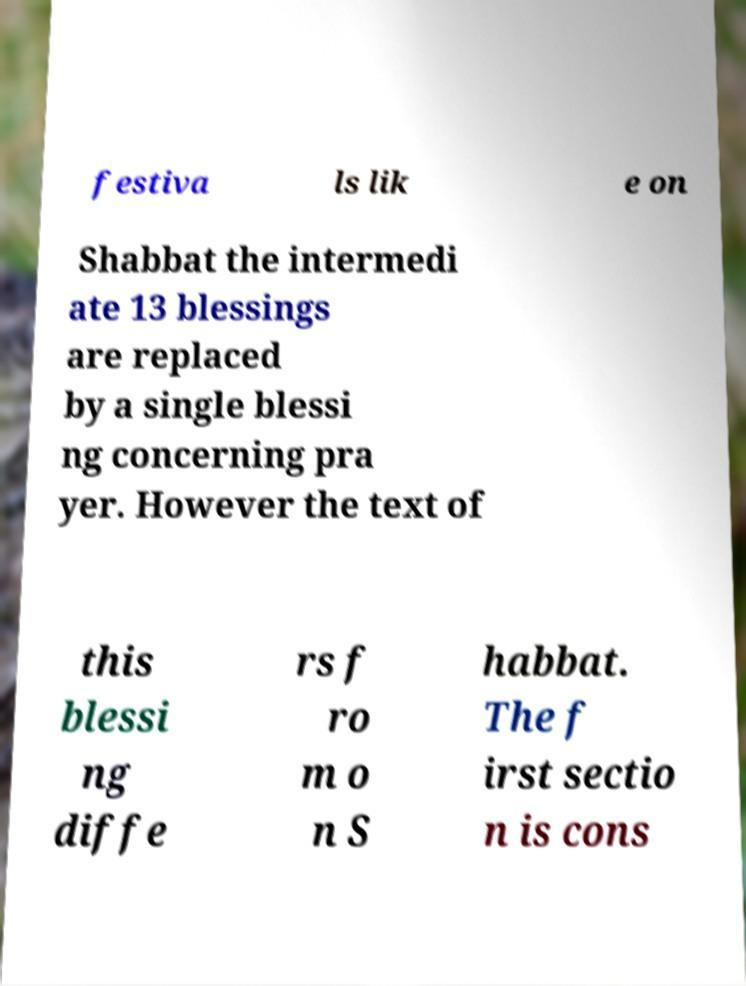Could you assist in decoding the text presented in this image and type it out clearly? festiva ls lik e on Shabbat the intermedi ate 13 blessings are replaced by a single blessi ng concerning pra yer. However the text of this blessi ng diffe rs f ro m o n S habbat. The f irst sectio n is cons 